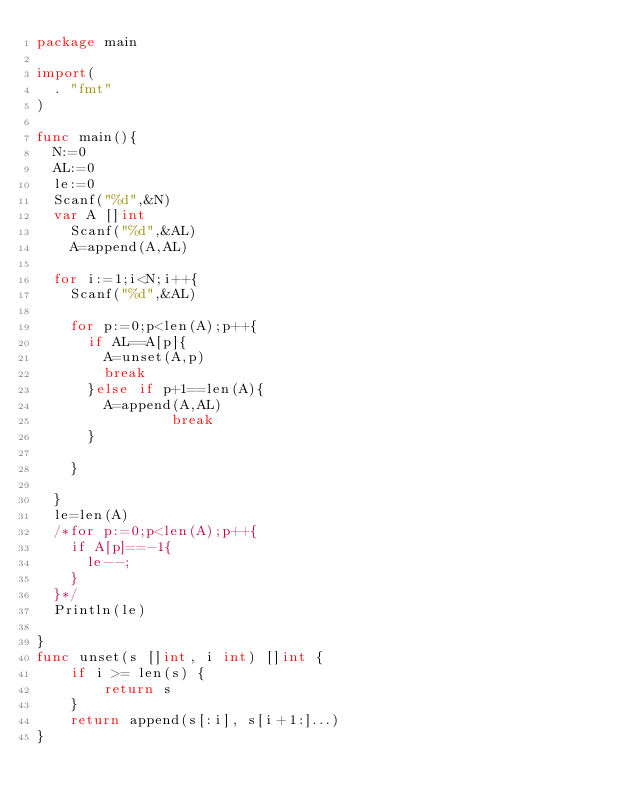Convert code to text. <code><loc_0><loc_0><loc_500><loc_500><_Go_>package main

import(
	. "fmt"
)

func main(){
	N:=0
	AL:=0
	le:=0
	Scanf("%d",&N)
	var A []int
  	Scanf("%d",&AL)
  	A=append(A,AL)

	for i:=1;i<N;i++{
		Scanf("%d",&AL)
      	
		for p:=0;p<len(A);p++{
			if AL==A[p]{
				A=unset(A,p)
				break
			}else if p+1==len(A){
				A=append(A,AL)
              	break
			}

		}

	}
	le=len(A)
	/*for p:=0;p<len(A);p++{
		if A[p]==-1{
			le--;
		}
	}*/
	Println(le)

}
func unset(s []int, i int) []int {
    if i >= len(s) {
        return s
    }
    return append(s[:i], s[i+1:]...)
}</code> 